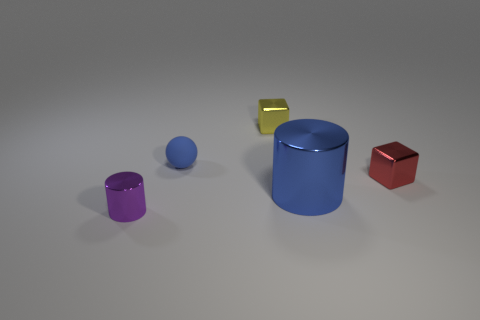Add 5 tiny things. How many objects exist? 10 Subtract all cylinders. How many objects are left? 3 Add 2 blue things. How many blue things are left? 4 Add 4 large blue shiny cylinders. How many large blue shiny cylinders exist? 5 Subtract 0 cyan blocks. How many objects are left? 5 Subtract all small purple cylinders. Subtract all tiny blocks. How many objects are left? 2 